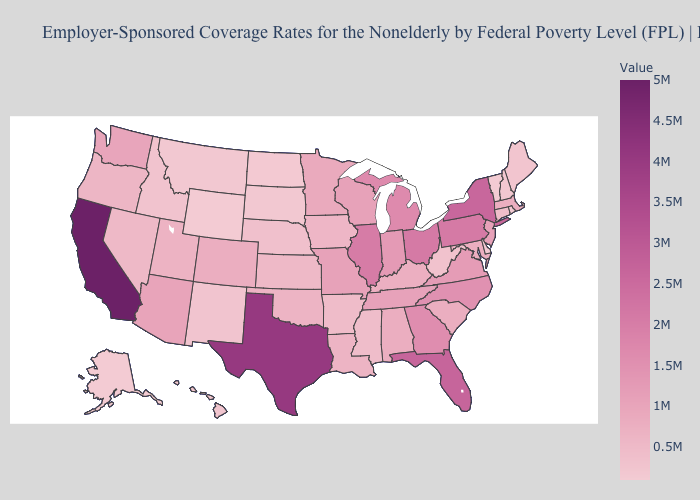Does Alaska have the highest value in the USA?
Keep it brief. No. Which states have the highest value in the USA?
Answer briefly. California. Which states have the highest value in the USA?
Answer briefly. California. Is the legend a continuous bar?
Quick response, please. Yes. Does Missouri have the highest value in the MidWest?
Quick response, please. No. Which states have the lowest value in the MidWest?
Give a very brief answer. North Dakota. Does South Dakota have a higher value than Alabama?
Quick response, please. No. 